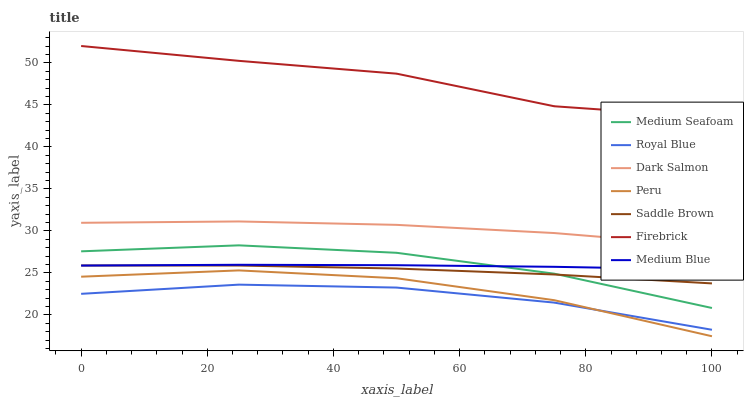Does Medium Blue have the minimum area under the curve?
Answer yes or no. No. Does Medium Blue have the maximum area under the curve?
Answer yes or no. No. Is Dark Salmon the smoothest?
Answer yes or no. No. Is Dark Salmon the roughest?
Answer yes or no. No. Does Medium Blue have the lowest value?
Answer yes or no. No. Does Medium Blue have the highest value?
Answer yes or no. No. Is Royal Blue less than Dark Salmon?
Answer yes or no. Yes. Is Saddle Brown greater than Peru?
Answer yes or no. Yes. Does Royal Blue intersect Dark Salmon?
Answer yes or no. No. 